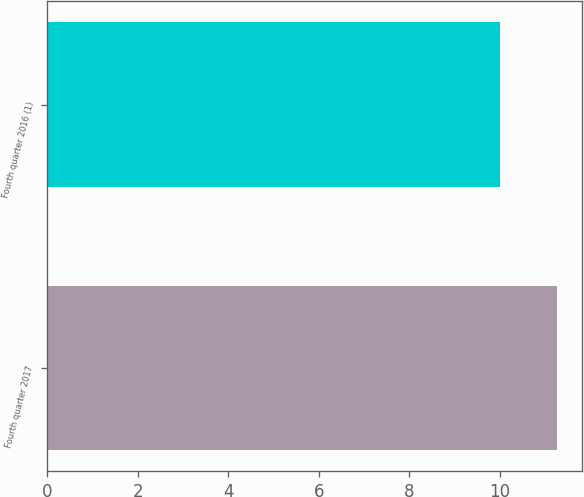Convert chart to OTSL. <chart><loc_0><loc_0><loc_500><loc_500><bar_chart><fcel>Fourth quarter 2017<fcel>Fourth quarter 2016 (1)<nl><fcel>11.25<fcel>10<nl></chart> 